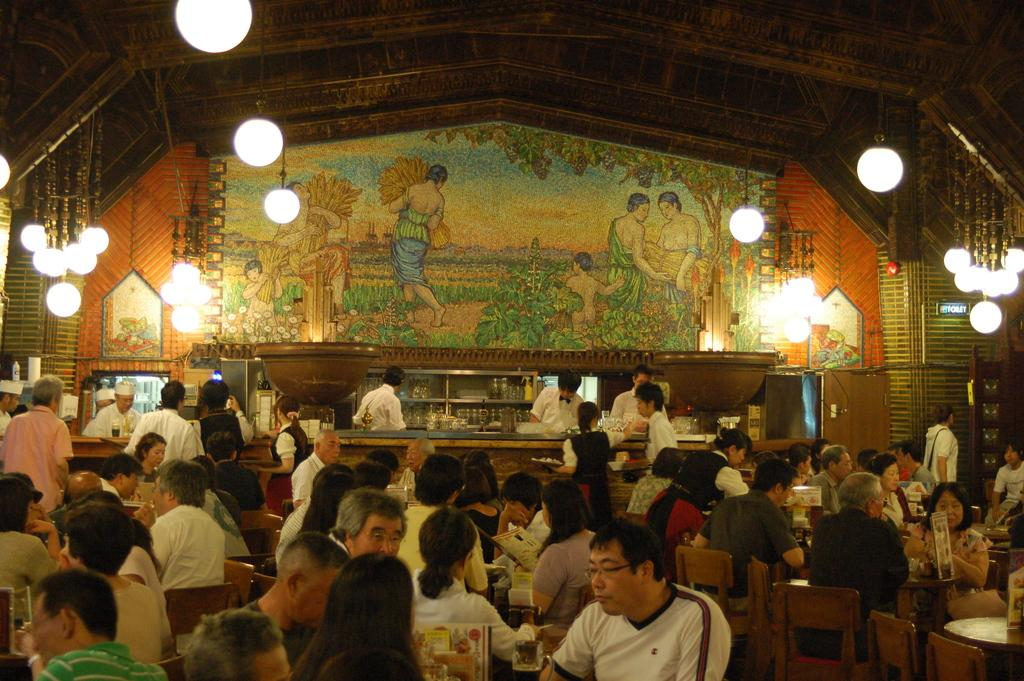What are the people in the image doing? There is a group of people sitting on chairs in the image. What else can be seen in the image besides the people? There are tables, lights, bottles, boards, and glasses in the image. What is on the wall in the background? There is a painting on the wall in the background. Can you tell me how many potatoes are on the table in the image? There are no potatoes present in the image; the items visible on the tables are bottles, boards, and glasses. 